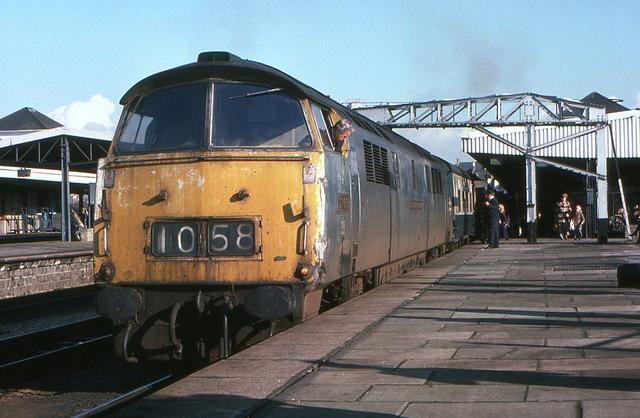What number is on the front of the train?
Give a very brief answer. 1058. Does the train have lights on?
Concise answer only. No. Is this train new?
Short answer required. No. Where is the train?
Give a very brief answer. Station. What does the numbers stand for?
Answer briefly. Train number. How many people are shown?
Be succinct. 5. How many people are waiting on the train?
Give a very brief answer. 4. What numbers are on the train's front?
Keep it brief. 1058. 